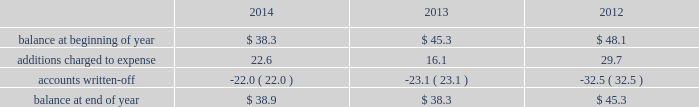Republic services , inc .
Notes to consolidated financial statements 2014 ( continued ) credit exposure , we continually monitor the credit worthiness of the financial institutions where we have deposits .
Concentrations of credit risk with respect to trade accounts receivable are limited due to the wide variety of customers and markets in which we provide services , as well as the dispersion of our operations across many geographic areas .
We provide services to commercial , industrial , municipal and residential customers in the united states and puerto rico .
We perform ongoing credit evaluations of our customers , but generally do not require collateral to support customer receivables .
We establish an allowance for doubtful accounts based on various factors including the credit risk of specific customers , age of receivables outstanding , historical trends , economic conditions and other information .
Accounts receivable , net accounts receivable represent receivables from customers for collection , transfer , recycling , disposal and other services .
Our receivables are recorded when billed or when the related revenue is earned , if earlier , and represent claims against third parties that will be settled in cash .
The carrying value of our receivables , net of the allowance for doubtful accounts and customer credits , represents their estimated net realizable value .
Provisions for doubtful accounts are evaluated on a monthly basis and are recorded based on our historical collection experience , the age of the receivables , specific customer information and economic conditions .
We also review outstanding balances on an account-specific basis .
In general , reserves are provided for accounts receivable in excess of 90 days outstanding .
Past due receivable balances are written-off when our collection efforts have been unsuccessful in collecting amounts due .
The table reflects the activity in our allowance for doubtful accounts for the years ended december 31: .
Restricted cash and marketable securities as of december 31 , 2014 , we had $ 115.6 million of restricted cash and marketable securities .
We obtain funds through the issuance of tax-exempt bonds for the purpose of financing qualifying expenditures at our landfills , transfer stations , collection and recycling centers .
The funds are deposited directly into trust accounts by the bonding authorities at the time of issuance .
As the use of these funds is contractually restricted , and we do not have the ability to use these funds for general operating purposes , they are classified as restricted cash and marketable securities in our consolidated balance sheets .
In the normal course of business , we may be required to provide financial assurance to governmental agencies and a variety of other entities in connection with municipal residential collection contracts , closure or post- closure of landfills , environmental remediation , environmental permits , and business licenses and permits as a financial guarantee of our performance .
At several of our landfills , we satisfy financial assurance requirements by depositing cash into restricted trust funds or escrow accounts .
Property and equipment we record property and equipment at cost .
Expenditures for major additions and improvements to facilities are capitalized , while maintenance and repairs are charged to expense as incurred .
When property is retired or otherwise disposed , the related cost and accumulated depreciation are removed from the accounts and any resulting gain or loss is reflected in the consolidated statements of income. .
As of december 31 , 2014 what was the ratio of the restricted cash and marketable securities to the balance in allowance for doubtful accounts? 
Rationale: the ratio of the restricted cash and marketable securities to the balance in allowance for doubtful accounts at december 312014 was 2.97 to1
Computations: (115.6 / 38.9)
Answer: 2.97172. 